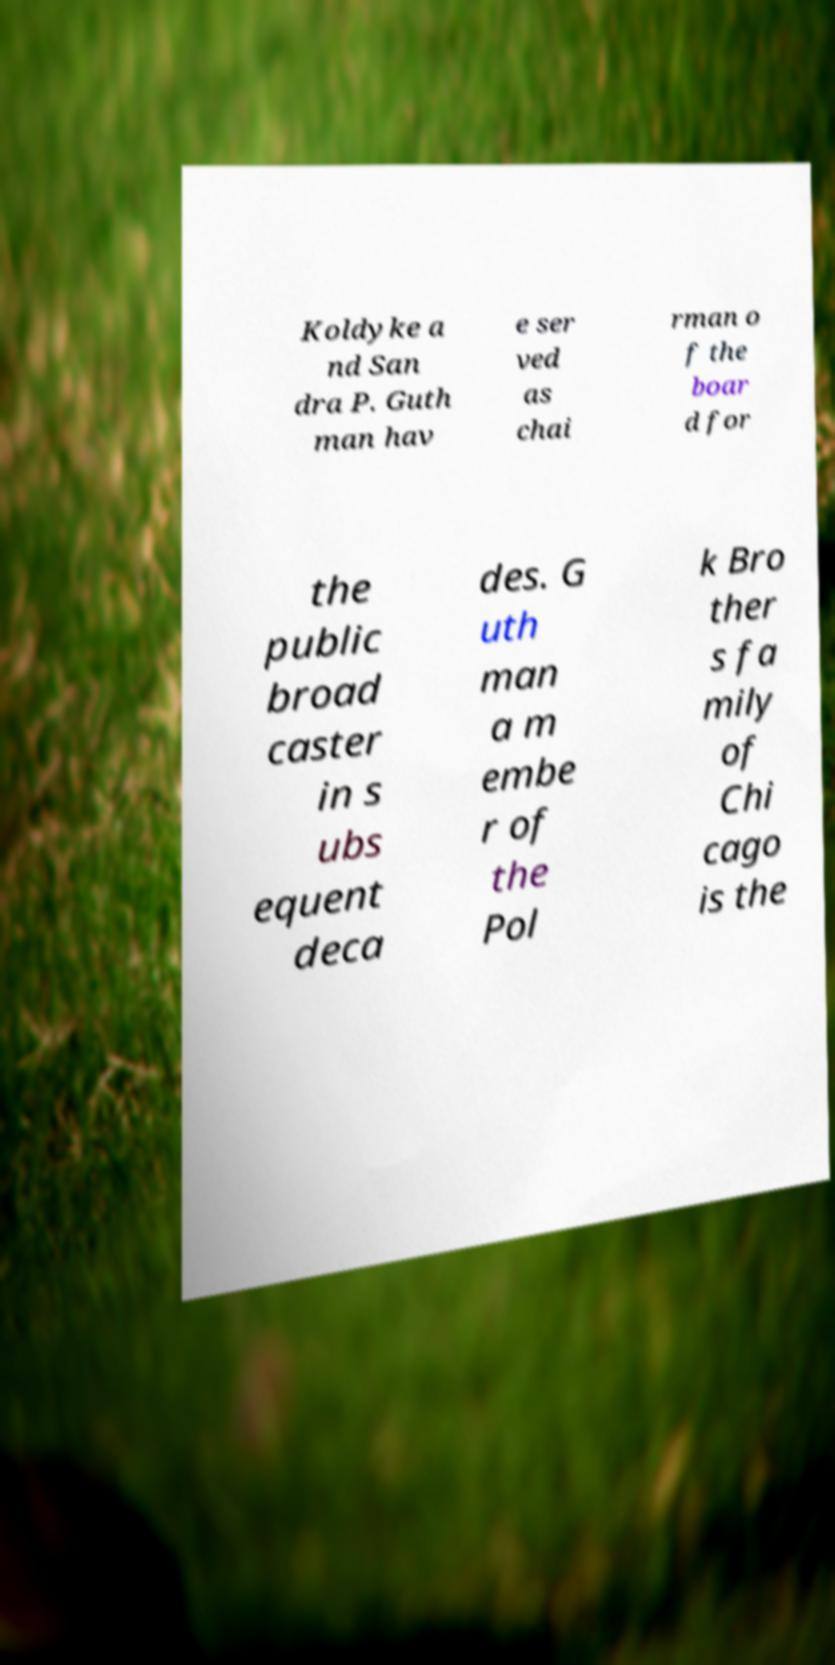Could you extract and type out the text from this image? Koldyke a nd San dra P. Guth man hav e ser ved as chai rman o f the boar d for the public broad caster in s ubs equent deca des. G uth man a m embe r of the Pol k Bro ther s fa mily of Chi cago is the 